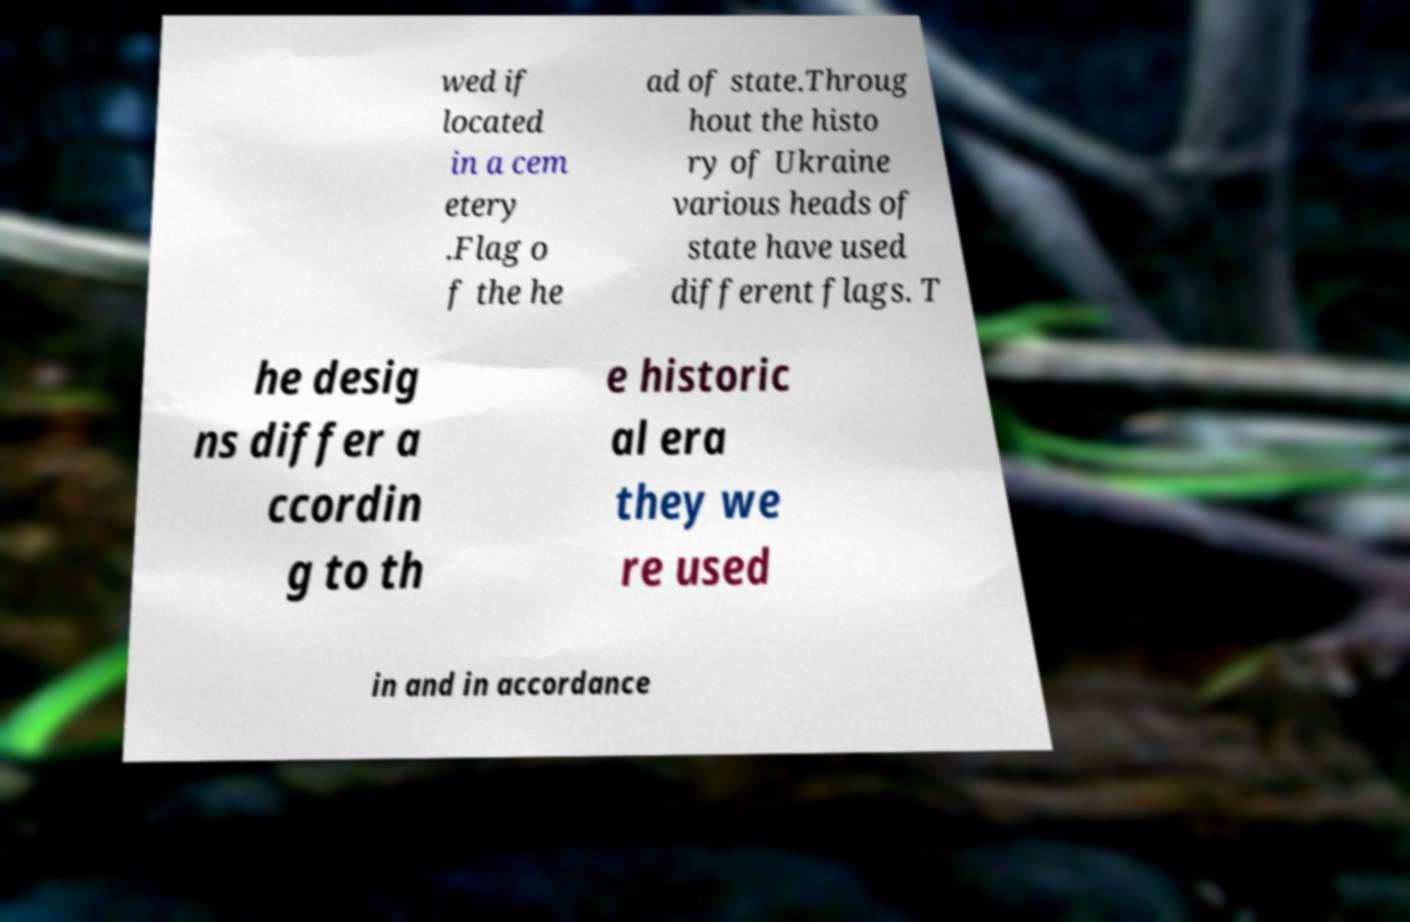Please identify and transcribe the text found in this image. wed if located in a cem etery .Flag o f the he ad of state.Throug hout the histo ry of Ukraine various heads of state have used different flags. T he desig ns differ a ccordin g to th e historic al era they we re used in and in accordance 